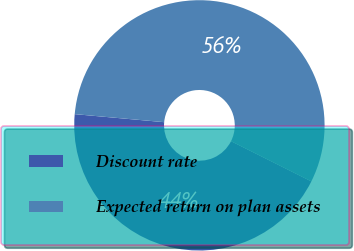Convert chart. <chart><loc_0><loc_0><loc_500><loc_500><pie_chart><fcel>Discount rate<fcel>Expected return on plan assets<nl><fcel>44.04%<fcel>55.96%<nl></chart> 